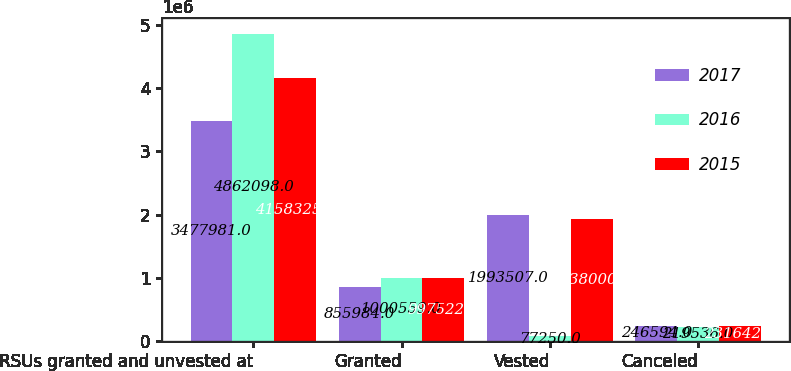Convert chart to OTSL. <chart><loc_0><loc_0><loc_500><loc_500><stacked_bar_chart><ecel><fcel>RSUs granted and unvested at<fcel>Granted<fcel>Vested<fcel>Canceled<nl><fcel>2017<fcel>3.47798e+06<fcel>855984<fcel>1.99351e+06<fcel>246594<nl><fcel>2016<fcel>4.8621e+06<fcel>1.00056e+06<fcel>77250<fcel>219536<nl><fcel>2015<fcel>4.15832e+06<fcel>997522<fcel>1.938e+06<fcel>231642<nl></chart> 